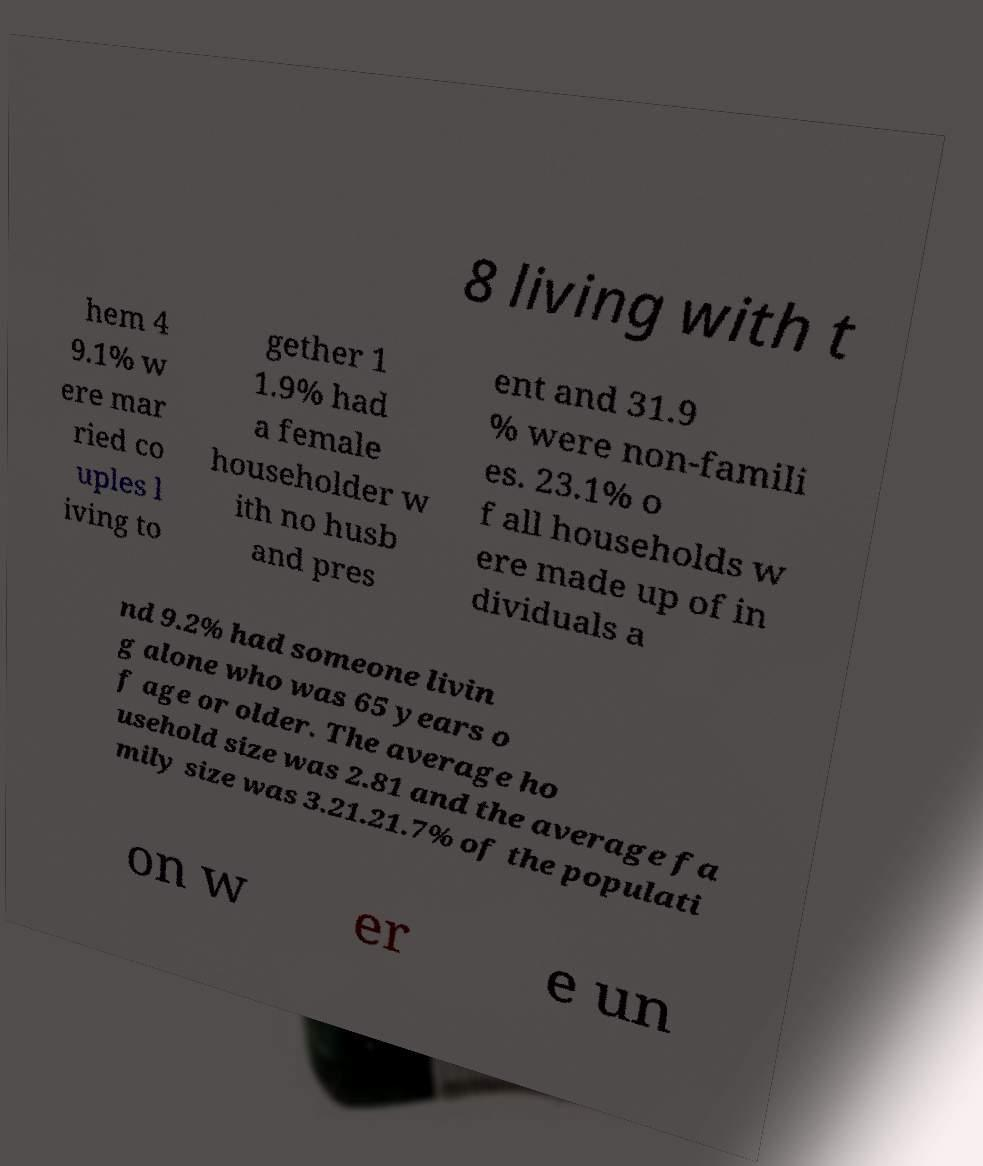What messages or text are displayed in this image? I need them in a readable, typed format. 8 living with t hem 4 9.1% w ere mar ried co uples l iving to gether 1 1.9% had a female householder w ith no husb and pres ent and 31.9 % were non-famili es. 23.1% o f all households w ere made up of in dividuals a nd 9.2% had someone livin g alone who was 65 years o f age or older. The average ho usehold size was 2.81 and the average fa mily size was 3.21.21.7% of the populati on w er e un 